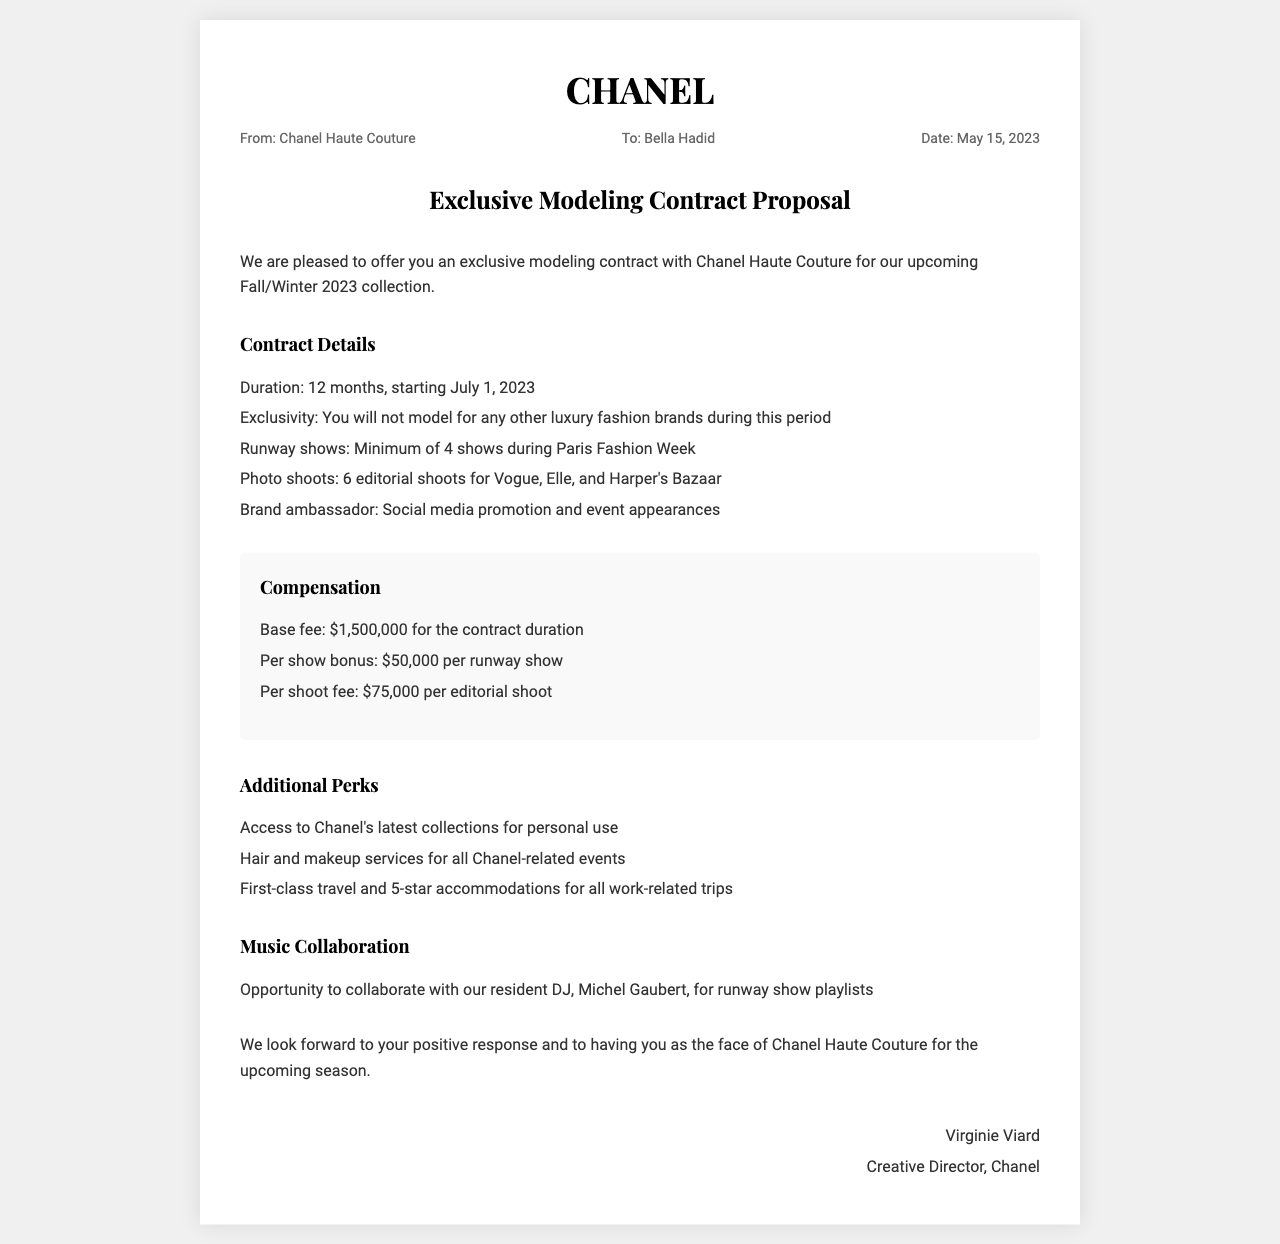what is the designer brand mentioned in the contract? The contract is made with Chanel Haute Couture as stated in the document.
Answer: Chanel Haute Couture what is the duration of the contract? The duration mentioned in the document is 12 months.
Answer: 12 months when does the contract start? The starting date of the contract is specified in the document as July 1, 2023.
Answer: July 1, 2023 how much is the base fee for the contract duration? The document states that the base fee for the entire duration is $1,500,000.
Answer: $1,500,000 how many runway shows are guaranteed during Paris Fashion Week? The document specifies a minimum of 4 runway shows during Paris Fashion Week.
Answer: 4 shows what additional service is provided for all Chanel-related events? The document mentions that hair and makeup services will be provided for all events related to Chanel.
Answer: Hair and makeup services who is the Creative Director of Chanel? The document provides the name of the Creative Director as Virginie Viard.
Answer: Virginie Viard what opportunity is mentioned regarding music collaboration? An opportunity to collaborate with the resident DJ for runway show playlists is noted in the document.
Answer: Collaborate with DJ Michel Gaubert what is the per show bonus for runway shows? The document indicates that the per show bonus is $50,000 for each runway show.
Answer: $50,000 